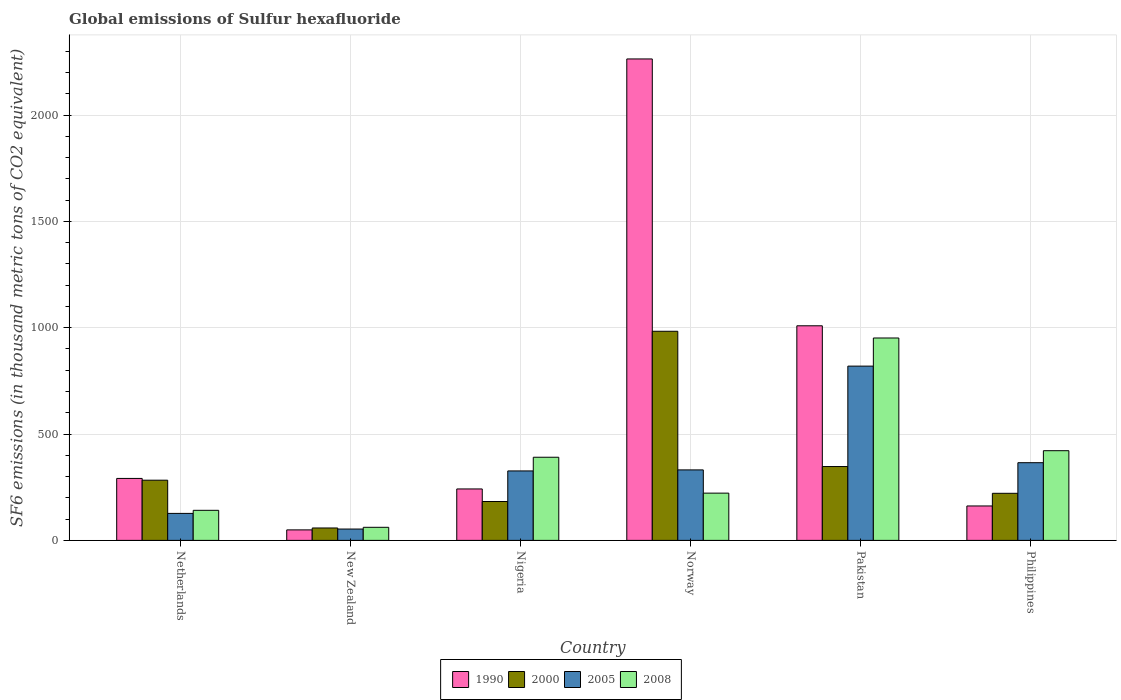How many different coloured bars are there?
Your answer should be very brief. 4. How many groups of bars are there?
Ensure brevity in your answer.  6. Are the number of bars per tick equal to the number of legend labels?
Your answer should be very brief. Yes. How many bars are there on the 3rd tick from the left?
Your response must be concise. 4. What is the label of the 6th group of bars from the left?
Give a very brief answer. Philippines. In how many cases, is the number of bars for a given country not equal to the number of legend labels?
Keep it short and to the point. 0. What is the global emissions of Sulfur hexafluoride in 1990 in New Zealand?
Keep it short and to the point. 49.4. Across all countries, what is the maximum global emissions of Sulfur hexafluoride in 2005?
Ensure brevity in your answer.  819.4. Across all countries, what is the minimum global emissions of Sulfur hexafluoride in 1990?
Your answer should be very brief. 49.4. In which country was the global emissions of Sulfur hexafluoride in 1990 maximum?
Provide a succinct answer. Norway. In which country was the global emissions of Sulfur hexafluoride in 2000 minimum?
Your response must be concise. New Zealand. What is the total global emissions of Sulfur hexafluoride in 1990 in the graph?
Offer a very short reply. 4017.1. What is the difference between the global emissions of Sulfur hexafluoride in 1990 in Netherlands and that in Nigeria?
Provide a short and direct response. 49.4. What is the difference between the global emissions of Sulfur hexafluoride in 2008 in New Zealand and the global emissions of Sulfur hexafluoride in 1990 in Netherlands?
Keep it short and to the point. -229.8. What is the average global emissions of Sulfur hexafluoride in 2000 per country?
Your answer should be very brief. 346. What is the difference between the global emissions of Sulfur hexafluoride of/in 1990 and global emissions of Sulfur hexafluoride of/in 2005 in Pakistan?
Provide a succinct answer. 189.6. What is the ratio of the global emissions of Sulfur hexafluoride in 1990 in Pakistan to that in Philippines?
Make the answer very short. 6.23. Is the global emissions of Sulfur hexafluoride in 2000 in Norway less than that in Pakistan?
Give a very brief answer. No. What is the difference between the highest and the second highest global emissions of Sulfur hexafluoride in 2005?
Provide a short and direct response. -488. What is the difference between the highest and the lowest global emissions of Sulfur hexafluoride in 2005?
Keep it short and to the point. 766. In how many countries, is the global emissions of Sulfur hexafluoride in 1990 greater than the average global emissions of Sulfur hexafluoride in 1990 taken over all countries?
Your answer should be very brief. 2. Is it the case that in every country, the sum of the global emissions of Sulfur hexafluoride in 2008 and global emissions of Sulfur hexafluoride in 2000 is greater than the sum of global emissions of Sulfur hexafluoride in 2005 and global emissions of Sulfur hexafluoride in 1990?
Ensure brevity in your answer.  No. What does the 3rd bar from the right in Pakistan represents?
Your answer should be compact. 2000. How many bars are there?
Keep it short and to the point. 24. Are all the bars in the graph horizontal?
Your answer should be compact. No. Are the values on the major ticks of Y-axis written in scientific E-notation?
Keep it short and to the point. No. Does the graph contain any zero values?
Your answer should be very brief. No. Where does the legend appear in the graph?
Offer a terse response. Bottom center. How are the legend labels stacked?
Give a very brief answer. Horizontal. What is the title of the graph?
Keep it short and to the point. Global emissions of Sulfur hexafluoride. What is the label or title of the X-axis?
Ensure brevity in your answer.  Country. What is the label or title of the Y-axis?
Provide a short and direct response. SF6 emissions (in thousand metric tons of CO2 equivalent). What is the SF6 emissions (in thousand metric tons of CO2 equivalent) in 1990 in Netherlands?
Offer a terse response. 291.3. What is the SF6 emissions (in thousand metric tons of CO2 equivalent) in 2000 in Netherlands?
Provide a short and direct response. 283. What is the SF6 emissions (in thousand metric tons of CO2 equivalent) of 2005 in Netherlands?
Your response must be concise. 126.9. What is the SF6 emissions (in thousand metric tons of CO2 equivalent) of 2008 in Netherlands?
Your response must be concise. 141.4. What is the SF6 emissions (in thousand metric tons of CO2 equivalent) in 1990 in New Zealand?
Ensure brevity in your answer.  49.4. What is the SF6 emissions (in thousand metric tons of CO2 equivalent) of 2000 in New Zealand?
Provide a short and direct response. 58.4. What is the SF6 emissions (in thousand metric tons of CO2 equivalent) in 2005 in New Zealand?
Ensure brevity in your answer.  53.4. What is the SF6 emissions (in thousand metric tons of CO2 equivalent) in 2008 in New Zealand?
Your response must be concise. 61.5. What is the SF6 emissions (in thousand metric tons of CO2 equivalent) in 1990 in Nigeria?
Give a very brief answer. 241.9. What is the SF6 emissions (in thousand metric tons of CO2 equivalent) of 2000 in Nigeria?
Your response must be concise. 182.8. What is the SF6 emissions (in thousand metric tons of CO2 equivalent) in 2005 in Nigeria?
Your answer should be compact. 326.6. What is the SF6 emissions (in thousand metric tons of CO2 equivalent) in 2008 in Nigeria?
Make the answer very short. 390.9. What is the SF6 emissions (in thousand metric tons of CO2 equivalent) in 1990 in Norway?
Make the answer very short. 2263.6. What is the SF6 emissions (in thousand metric tons of CO2 equivalent) in 2000 in Norway?
Your response must be concise. 983.2. What is the SF6 emissions (in thousand metric tons of CO2 equivalent) of 2005 in Norway?
Make the answer very short. 331.4. What is the SF6 emissions (in thousand metric tons of CO2 equivalent) in 2008 in Norway?
Give a very brief answer. 222.2. What is the SF6 emissions (in thousand metric tons of CO2 equivalent) in 1990 in Pakistan?
Make the answer very short. 1009. What is the SF6 emissions (in thousand metric tons of CO2 equivalent) in 2000 in Pakistan?
Offer a very short reply. 347.2. What is the SF6 emissions (in thousand metric tons of CO2 equivalent) of 2005 in Pakistan?
Ensure brevity in your answer.  819.4. What is the SF6 emissions (in thousand metric tons of CO2 equivalent) of 2008 in Pakistan?
Your answer should be very brief. 951.6. What is the SF6 emissions (in thousand metric tons of CO2 equivalent) of 1990 in Philippines?
Provide a short and direct response. 161.9. What is the SF6 emissions (in thousand metric tons of CO2 equivalent) in 2000 in Philippines?
Your answer should be very brief. 221.4. What is the SF6 emissions (in thousand metric tons of CO2 equivalent) of 2005 in Philippines?
Your response must be concise. 365.3. What is the SF6 emissions (in thousand metric tons of CO2 equivalent) of 2008 in Philippines?
Offer a very short reply. 421.7. Across all countries, what is the maximum SF6 emissions (in thousand metric tons of CO2 equivalent) in 1990?
Your answer should be compact. 2263.6. Across all countries, what is the maximum SF6 emissions (in thousand metric tons of CO2 equivalent) of 2000?
Make the answer very short. 983.2. Across all countries, what is the maximum SF6 emissions (in thousand metric tons of CO2 equivalent) in 2005?
Give a very brief answer. 819.4. Across all countries, what is the maximum SF6 emissions (in thousand metric tons of CO2 equivalent) in 2008?
Make the answer very short. 951.6. Across all countries, what is the minimum SF6 emissions (in thousand metric tons of CO2 equivalent) in 1990?
Your answer should be very brief. 49.4. Across all countries, what is the minimum SF6 emissions (in thousand metric tons of CO2 equivalent) of 2000?
Provide a succinct answer. 58.4. Across all countries, what is the minimum SF6 emissions (in thousand metric tons of CO2 equivalent) in 2005?
Ensure brevity in your answer.  53.4. Across all countries, what is the minimum SF6 emissions (in thousand metric tons of CO2 equivalent) of 2008?
Offer a terse response. 61.5. What is the total SF6 emissions (in thousand metric tons of CO2 equivalent) of 1990 in the graph?
Ensure brevity in your answer.  4017.1. What is the total SF6 emissions (in thousand metric tons of CO2 equivalent) in 2000 in the graph?
Give a very brief answer. 2076. What is the total SF6 emissions (in thousand metric tons of CO2 equivalent) of 2005 in the graph?
Keep it short and to the point. 2023. What is the total SF6 emissions (in thousand metric tons of CO2 equivalent) in 2008 in the graph?
Provide a short and direct response. 2189.3. What is the difference between the SF6 emissions (in thousand metric tons of CO2 equivalent) of 1990 in Netherlands and that in New Zealand?
Your answer should be very brief. 241.9. What is the difference between the SF6 emissions (in thousand metric tons of CO2 equivalent) in 2000 in Netherlands and that in New Zealand?
Ensure brevity in your answer.  224.6. What is the difference between the SF6 emissions (in thousand metric tons of CO2 equivalent) of 2005 in Netherlands and that in New Zealand?
Your answer should be very brief. 73.5. What is the difference between the SF6 emissions (in thousand metric tons of CO2 equivalent) of 2008 in Netherlands and that in New Zealand?
Make the answer very short. 79.9. What is the difference between the SF6 emissions (in thousand metric tons of CO2 equivalent) of 1990 in Netherlands and that in Nigeria?
Your response must be concise. 49.4. What is the difference between the SF6 emissions (in thousand metric tons of CO2 equivalent) in 2000 in Netherlands and that in Nigeria?
Ensure brevity in your answer.  100.2. What is the difference between the SF6 emissions (in thousand metric tons of CO2 equivalent) of 2005 in Netherlands and that in Nigeria?
Your answer should be very brief. -199.7. What is the difference between the SF6 emissions (in thousand metric tons of CO2 equivalent) in 2008 in Netherlands and that in Nigeria?
Offer a terse response. -249.5. What is the difference between the SF6 emissions (in thousand metric tons of CO2 equivalent) of 1990 in Netherlands and that in Norway?
Keep it short and to the point. -1972.3. What is the difference between the SF6 emissions (in thousand metric tons of CO2 equivalent) in 2000 in Netherlands and that in Norway?
Offer a terse response. -700.2. What is the difference between the SF6 emissions (in thousand metric tons of CO2 equivalent) in 2005 in Netherlands and that in Norway?
Give a very brief answer. -204.5. What is the difference between the SF6 emissions (in thousand metric tons of CO2 equivalent) in 2008 in Netherlands and that in Norway?
Your answer should be very brief. -80.8. What is the difference between the SF6 emissions (in thousand metric tons of CO2 equivalent) in 1990 in Netherlands and that in Pakistan?
Offer a very short reply. -717.7. What is the difference between the SF6 emissions (in thousand metric tons of CO2 equivalent) in 2000 in Netherlands and that in Pakistan?
Offer a very short reply. -64.2. What is the difference between the SF6 emissions (in thousand metric tons of CO2 equivalent) in 2005 in Netherlands and that in Pakistan?
Ensure brevity in your answer.  -692.5. What is the difference between the SF6 emissions (in thousand metric tons of CO2 equivalent) in 2008 in Netherlands and that in Pakistan?
Your answer should be very brief. -810.2. What is the difference between the SF6 emissions (in thousand metric tons of CO2 equivalent) of 1990 in Netherlands and that in Philippines?
Offer a very short reply. 129.4. What is the difference between the SF6 emissions (in thousand metric tons of CO2 equivalent) in 2000 in Netherlands and that in Philippines?
Keep it short and to the point. 61.6. What is the difference between the SF6 emissions (in thousand metric tons of CO2 equivalent) of 2005 in Netherlands and that in Philippines?
Make the answer very short. -238.4. What is the difference between the SF6 emissions (in thousand metric tons of CO2 equivalent) in 2008 in Netherlands and that in Philippines?
Your response must be concise. -280.3. What is the difference between the SF6 emissions (in thousand metric tons of CO2 equivalent) in 1990 in New Zealand and that in Nigeria?
Offer a terse response. -192.5. What is the difference between the SF6 emissions (in thousand metric tons of CO2 equivalent) of 2000 in New Zealand and that in Nigeria?
Your answer should be very brief. -124.4. What is the difference between the SF6 emissions (in thousand metric tons of CO2 equivalent) of 2005 in New Zealand and that in Nigeria?
Your answer should be very brief. -273.2. What is the difference between the SF6 emissions (in thousand metric tons of CO2 equivalent) of 2008 in New Zealand and that in Nigeria?
Your answer should be very brief. -329.4. What is the difference between the SF6 emissions (in thousand metric tons of CO2 equivalent) of 1990 in New Zealand and that in Norway?
Your answer should be compact. -2214.2. What is the difference between the SF6 emissions (in thousand metric tons of CO2 equivalent) in 2000 in New Zealand and that in Norway?
Your answer should be compact. -924.8. What is the difference between the SF6 emissions (in thousand metric tons of CO2 equivalent) of 2005 in New Zealand and that in Norway?
Your answer should be very brief. -278. What is the difference between the SF6 emissions (in thousand metric tons of CO2 equivalent) of 2008 in New Zealand and that in Norway?
Provide a short and direct response. -160.7. What is the difference between the SF6 emissions (in thousand metric tons of CO2 equivalent) of 1990 in New Zealand and that in Pakistan?
Keep it short and to the point. -959.6. What is the difference between the SF6 emissions (in thousand metric tons of CO2 equivalent) in 2000 in New Zealand and that in Pakistan?
Provide a succinct answer. -288.8. What is the difference between the SF6 emissions (in thousand metric tons of CO2 equivalent) in 2005 in New Zealand and that in Pakistan?
Your answer should be compact. -766. What is the difference between the SF6 emissions (in thousand metric tons of CO2 equivalent) in 2008 in New Zealand and that in Pakistan?
Provide a short and direct response. -890.1. What is the difference between the SF6 emissions (in thousand metric tons of CO2 equivalent) in 1990 in New Zealand and that in Philippines?
Your response must be concise. -112.5. What is the difference between the SF6 emissions (in thousand metric tons of CO2 equivalent) in 2000 in New Zealand and that in Philippines?
Your answer should be compact. -163. What is the difference between the SF6 emissions (in thousand metric tons of CO2 equivalent) of 2005 in New Zealand and that in Philippines?
Give a very brief answer. -311.9. What is the difference between the SF6 emissions (in thousand metric tons of CO2 equivalent) in 2008 in New Zealand and that in Philippines?
Offer a terse response. -360.2. What is the difference between the SF6 emissions (in thousand metric tons of CO2 equivalent) in 1990 in Nigeria and that in Norway?
Give a very brief answer. -2021.7. What is the difference between the SF6 emissions (in thousand metric tons of CO2 equivalent) in 2000 in Nigeria and that in Norway?
Offer a terse response. -800.4. What is the difference between the SF6 emissions (in thousand metric tons of CO2 equivalent) in 2005 in Nigeria and that in Norway?
Your answer should be very brief. -4.8. What is the difference between the SF6 emissions (in thousand metric tons of CO2 equivalent) in 2008 in Nigeria and that in Norway?
Offer a terse response. 168.7. What is the difference between the SF6 emissions (in thousand metric tons of CO2 equivalent) of 1990 in Nigeria and that in Pakistan?
Keep it short and to the point. -767.1. What is the difference between the SF6 emissions (in thousand metric tons of CO2 equivalent) in 2000 in Nigeria and that in Pakistan?
Offer a very short reply. -164.4. What is the difference between the SF6 emissions (in thousand metric tons of CO2 equivalent) in 2005 in Nigeria and that in Pakistan?
Offer a terse response. -492.8. What is the difference between the SF6 emissions (in thousand metric tons of CO2 equivalent) of 2008 in Nigeria and that in Pakistan?
Provide a succinct answer. -560.7. What is the difference between the SF6 emissions (in thousand metric tons of CO2 equivalent) of 1990 in Nigeria and that in Philippines?
Your answer should be very brief. 80. What is the difference between the SF6 emissions (in thousand metric tons of CO2 equivalent) of 2000 in Nigeria and that in Philippines?
Offer a terse response. -38.6. What is the difference between the SF6 emissions (in thousand metric tons of CO2 equivalent) of 2005 in Nigeria and that in Philippines?
Provide a short and direct response. -38.7. What is the difference between the SF6 emissions (in thousand metric tons of CO2 equivalent) in 2008 in Nigeria and that in Philippines?
Offer a very short reply. -30.8. What is the difference between the SF6 emissions (in thousand metric tons of CO2 equivalent) in 1990 in Norway and that in Pakistan?
Your response must be concise. 1254.6. What is the difference between the SF6 emissions (in thousand metric tons of CO2 equivalent) in 2000 in Norway and that in Pakistan?
Your answer should be very brief. 636. What is the difference between the SF6 emissions (in thousand metric tons of CO2 equivalent) in 2005 in Norway and that in Pakistan?
Keep it short and to the point. -488. What is the difference between the SF6 emissions (in thousand metric tons of CO2 equivalent) in 2008 in Norway and that in Pakistan?
Offer a terse response. -729.4. What is the difference between the SF6 emissions (in thousand metric tons of CO2 equivalent) of 1990 in Norway and that in Philippines?
Provide a short and direct response. 2101.7. What is the difference between the SF6 emissions (in thousand metric tons of CO2 equivalent) in 2000 in Norway and that in Philippines?
Offer a terse response. 761.8. What is the difference between the SF6 emissions (in thousand metric tons of CO2 equivalent) of 2005 in Norway and that in Philippines?
Your answer should be very brief. -33.9. What is the difference between the SF6 emissions (in thousand metric tons of CO2 equivalent) in 2008 in Norway and that in Philippines?
Your answer should be compact. -199.5. What is the difference between the SF6 emissions (in thousand metric tons of CO2 equivalent) of 1990 in Pakistan and that in Philippines?
Keep it short and to the point. 847.1. What is the difference between the SF6 emissions (in thousand metric tons of CO2 equivalent) in 2000 in Pakistan and that in Philippines?
Give a very brief answer. 125.8. What is the difference between the SF6 emissions (in thousand metric tons of CO2 equivalent) of 2005 in Pakistan and that in Philippines?
Your response must be concise. 454.1. What is the difference between the SF6 emissions (in thousand metric tons of CO2 equivalent) in 2008 in Pakistan and that in Philippines?
Make the answer very short. 529.9. What is the difference between the SF6 emissions (in thousand metric tons of CO2 equivalent) of 1990 in Netherlands and the SF6 emissions (in thousand metric tons of CO2 equivalent) of 2000 in New Zealand?
Offer a terse response. 232.9. What is the difference between the SF6 emissions (in thousand metric tons of CO2 equivalent) of 1990 in Netherlands and the SF6 emissions (in thousand metric tons of CO2 equivalent) of 2005 in New Zealand?
Offer a terse response. 237.9. What is the difference between the SF6 emissions (in thousand metric tons of CO2 equivalent) in 1990 in Netherlands and the SF6 emissions (in thousand metric tons of CO2 equivalent) in 2008 in New Zealand?
Offer a very short reply. 229.8. What is the difference between the SF6 emissions (in thousand metric tons of CO2 equivalent) in 2000 in Netherlands and the SF6 emissions (in thousand metric tons of CO2 equivalent) in 2005 in New Zealand?
Your response must be concise. 229.6. What is the difference between the SF6 emissions (in thousand metric tons of CO2 equivalent) in 2000 in Netherlands and the SF6 emissions (in thousand metric tons of CO2 equivalent) in 2008 in New Zealand?
Give a very brief answer. 221.5. What is the difference between the SF6 emissions (in thousand metric tons of CO2 equivalent) of 2005 in Netherlands and the SF6 emissions (in thousand metric tons of CO2 equivalent) of 2008 in New Zealand?
Provide a short and direct response. 65.4. What is the difference between the SF6 emissions (in thousand metric tons of CO2 equivalent) in 1990 in Netherlands and the SF6 emissions (in thousand metric tons of CO2 equivalent) in 2000 in Nigeria?
Provide a short and direct response. 108.5. What is the difference between the SF6 emissions (in thousand metric tons of CO2 equivalent) in 1990 in Netherlands and the SF6 emissions (in thousand metric tons of CO2 equivalent) in 2005 in Nigeria?
Provide a succinct answer. -35.3. What is the difference between the SF6 emissions (in thousand metric tons of CO2 equivalent) in 1990 in Netherlands and the SF6 emissions (in thousand metric tons of CO2 equivalent) in 2008 in Nigeria?
Ensure brevity in your answer.  -99.6. What is the difference between the SF6 emissions (in thousand metric tons of CO2 equivalent) of 2000 in Netherlands and the SF6 emissions (in thousand metric tons of CO2 equivalent) of 2005 in Nigeria?
Your answer should be very brief. -43.6. What is the difference between the SF6 emissions (in thousand metric tons of CO2 equivalent) in 2000 in Netherlands and the SF6 emissions (in thousand metric tons of CO2 equivalent) in 2008 in Nigeria?
Your answer should be very brief. -107.9. What is the difference between the SF6 emissions (in thousand metric tons of CO2 equivalent) of 2005 in Netherlands and the SF6 emissions (in thousand metric tons of CO2 equivalent) of 2008 in Nigeria?
Your answer should be compact. -264. What is the difference between the SF6 emissions (in thousand metric tons of CO2 equivalent) of 1990 in Netherlands and the SF6 emissions (in thousand metric tons of CO2 equivalent) of 2000 in Norway?
Give a very brief answer. -691.9. What is the difference between the SF6 emissions (in thousand metric tons of CO2 equivalent) in 1990 in Netherlands and the SF6 emissions (in thousand metric tons of CO2 equivalent) in 2005 in Norway?
Keep it short and to the point. -40.1. What is the difference between the SF6 emissions (in thousand metric tons of CO2 equivalent) in 1990 in Netherlands and the SF6 emissions (in thousand metric tons of CO2 equivalent) in 2008 in Norway?
Ensure brevity in your answer.  69.1. What is the difference between the SF6 emissions (in thousand metric tons of CO2 equivalent) of 2000 in Netherlands and the SF6 emissions (in thousand metric tons of CO2 equivalent) of 2005 in Norway?
Keep it short and to the point. -48.4. What is the difference between the SF6 emissions (in thousand metric tons of CO2 equivalent) in 2000 in Netherlands and the SF6 emissions (in thousand metric tons of CO2 equivalent) in 2008 in Norway?
Provide a short and direct response. 60.8. What is the difference between the SF6 emissions (in thousand metric tons of CO2 equivalent) of 2005 in Netherlands and the SF6 emissions (in thousand metric tons of CO2 equivalent) of 2008 in Norway?
Make the answer very short. -95.3. What is the difference between the SF6 emissions (in thousand metric tons of CO2 equivalent) of 1990 in Netherlands and the SF6 emissions (in thousand metric tons of CO2 equivalent) of 2000 in Pakistan?
Your answer should be very brief. -55.9. What is the difference between the SF6 emissions (in thousand metric tons of CO2 equivalent) in 1990 in Netherlands and the SF6 emissions (in thousand metric tons of CO2 equivalent) in 2005 in Pakistan?
Provide a succinct answer. -528.1. What is the difference between the SF6 emissions (in thousand metric tons of CO2 equivalent) of 1990 in Netherlands and the SF6 emissions (in thousand metric tons of CO2 equivalent) of 2008 in Pakistan?
Give a very brief answer. -660.3. What is the difference between the SF6 emissions (in thousand metric tons of CO2 equivalent) of 2000 in Netherlands and the SF6 emissions (in thousand metric tons of CO2 equivalent) of 2005 in Pakistan?
Make the answer very short. -536.4. What is the difference between the SF6 emissions (in thousand metric tons of CO2 equivalent) in 2000 in Netherlands and the SF6 emissions (in thousand metric tons of CO2 equivalent) in 2008 in Pakistan?
Your answer should be compact. -668.6. What is the difference between the SF6 emissions (in thousand metric tons of CO2 equivalent) in 2005 in Netherlands and the SF6 emissions (in thousand metric tons of CO2 equivalent) in 2008 in Pakistan?
Offer a very short reply. -824.7. What is the difference between the SF6 emissions (in thousand metric tons of CO2 equivalent) of 1990 in Netherlands and the SF6 emissions (in thousand metric tons of CO2 equivalent) of 2000 in Philippines?
Offer a terse response. 69.9. What is the difference between the SF6 emissions (in thousand metric tons of CO2 equivalent) in 1990 in Netherlands and the SF6 emissions (in thousand metric tons of CO2 equivalent) in 2005 in Philippines?
Your response must be concise. -74. What is the difference between the SF6 emissions (in thousand metric tons of CO2 equivalent) of 1990 in Netherlands and the SF6 emissions (in thousand metric tons of CO2 equivalent) of 2008 in Philippines?
Your answer should be very brief. -130.4. What is the difference between the SF6 emissions (in thousand metric tons of CO2 equivalent) of 2000 in Netherlands and the SF6 emissions (in thousand metric tons of CO2 equivalent) of 2005 in Philippines?
Ensure brevity in your answer.  -82.3. What is the difference between the SF6 emissions (in thousand metric tons of CO2 equivalent) of 2000 in Netherlands and the SF6 emissions (in thousand metric tons of CO2 equivalent) of 2008 in Philippines?
Offer a terse response. -138.7. What is the difference between the SF6 emissions (in thousand metric tons of CO2 equivalent) in 2005 in Netherlands and the SF6 emissions (in thousand metric tons of CO2 equivalent) in 2008 in Philippines?
Your answer should be very brief. -294.8. What is the difference between the SF6 emissions (in thousand metric tons of CO2 equivalent) of 1990 in New Zealand and the SF6 emissions (in thousand metric tons of CO2 equivalent) of 2000 in Nigeria?
Your response must be concise. -133.4. What is the difference between the SF6 emissions (in thousand metric tons of CO2 equivalent) of 1990 in New Zealand and the SF6 emissions (in thousand metric tons of CO2 equivalent) of 2005 in Nigeria?
Ensure brevity in your answer.  -277.2. What is the difference between the SF6 emissions (in thousand metric tons of CO2 equivalent) in 1990 in New Zealand and the SF6 emissions (in thousand metric tons of CO2 equivalent) in 2008 in Nigeria?
Give a very brief answer. -341.5. What is the difference between the SF6 emissions (in thousand metric tons of CO2 equivalent) in 2000 in New Zealand and the SF6 emissions (in thousand metric tons of CO2 equivalent) in 2005 in Nigeria?
Offer a very short reply. -268.2. What is the difference between the SF6 emissions (in thousand metric tons of CO2 equivalent) in 2000 in New Zealand and the SF6 emissions (in thousand metric tons of CO2 equivalent) in 2008 in Nigeria?
Ensure brevity in your answer.  -332.5. What is the difference between the SF6 emissions (in thousand metric tons of CO2 equivalent) in 2005 in New Zealand and the SF6 emissions (in thousand metric tons of CO2 equivalent) in 2008 in Nigeria?
Make the answer very short. -337.5. What is the difference between the SF6 emissions (in thousand metric tons of CO2 equivalent) of 1990 in New Zealand and the SF6 emissions (in thousand metric tons of CO2 equivalent) of 2000 in Norway?
Ensure brevity in your answer.  -933.8. What is the difference between the SF6 emissions (in thousand metric tons of CO2 equivalent) in 1990 in New Zealand and the SF6 emissions (in thousand metric tons of CO2 equivalent) in 2005 in Norway?
Give a very brief answer. -282. What is the difference between the SF6 emissions (in thousand metric tons of CO2 equivalent) of 1990 in New Zealand and the SF6 emissions (in thousand metric tons of CO2 equivalent) of 2008 in Norway?
Give a very brief answer. -172.8. What is the difference between the SF6 emissions (in thousand metric tons of CO2 equivalent) in 2000 in New Zealand and the SF6 emissions (in thousand metric tons of CO2 equivalent) in 2005 in Norway?
Provide a succinct answer. -273. What is the difference between the SF6 emissions (in thousand metric tons of CO2 equivalent) in 2000 in New Zealand and the SF6 emissions (in thousand metric tons of CO2 equivalent) in 2008 in Norway?
Your response must be concise. -163.8. What is the difference between the SF6 emissions (in thousand metric tons of CO2 equivalent) of 2005 in New Zealand and the SF6 emissions (in thousand metric tons of CO2 equivalent) of 2008 in Norway?
Offer a terse response. -168.8. What is the difference between the SF6 emissions (in thousand metric tons of CO2 equivalent) of 1990 in New Zealand and the SF6 emissions (in thousand metric tons of CO2 equivalent) of 2000 in Pakistan?
Give a very brief answer. -297.8. What is the difference between the SF6 emissions (in thousand metric tons of CO2 equivalent) in 1990 in New Zealand and the SF6 emissions (in thousand metric tons of CO2 equivalent) in 2005 in Pakistan?
Make the answer very short. -770. What is the difference between the SF6 emissions (in thousand metric tons of CO2 equivalent) in 1990 in New Zealand and the SF6 emissions (in thousand metric tons of CO2 equivalent) in 2008 in Pakistan?
Give a very brief answer. -902.2. What is the difference between the SF6 emissions (in thousand metric tons of CO2 equivalent) of 2000 in New Zealand and the SF6 emissions (in thousand metric tons of CO2 equivalent) of 2005 in Pakistan?
Your answer should be compact. -761. What is the difference between the SF6 emissions (in thousand metric tons of CO2 equivalent) in 2000 in New Zealand and the SF6 emissions (in thousand metric tons of CO2 equivalent) in 2008 in Pakistan?
Keep it short and to the point. -893.2. What is the difference between the SF6 emissions (in thousand metric tons of CO2 equivalent) in 2005 in New Zealand and the SF6 emissions (in thousand metric tons of CO2 equivalent) in 2008 in Pakistan?
Your answer should be very brief. -898.2. What is the difference between the SF6 emissions (in thousand metric tons of CO2 equivalent) in 1990 in New Zealand and the SF6 emissions (in thousand metric tons of CO2 equivalent) in 2000 in Philippines?
Your answer should be compact. -172. What is the difference between the SF6 emissions (in thousand metric tons of CO2 equivalent) of 1990 in New Zealand and the SF6 emissions (in thousand metric tons of CO2 equivalent) of 2005 in Philippines?
Give a very brief answer. -315.9. What is the difference between the SF6 emissions (in thousand metric tons of CO2 equivalent) in 1990 in New Zealand and the SF6 emissions (in thousand metric tons of CO2 equivalent) in 2008 in Philippines?
Make the answer very short. -372.3. What is the difference between the SF6 emissions (in thousand metric tons of CO2 equivalent) of 2000 in New Zealand and the SF6 emissions (in thousand metric tons of CO2 equivalent) of 2005 in Philippines?
Offer a very short reply. -306.9. What is the difference between the SF6 emissions (in thousand metric tons of CO2 equivalent) in 2000 in New Zealand and the SF6 emissions (in thousand metric tons of CO2 equivalent) in 2008 in Philippines?
Your answer should be very brief. -363.3. What is the difference between the SF6 emissions (in thousand metric tons of CO2 equivalent) in 2005 in New Zealand and the SF6 emissions (in thousand metric tons of CO2 equivalent) in 2008 in Philippines?
Keep it short and to the point. -368.3. What is the difference between the SF6 emissions (in thousand metric tons of CO2 equivalent) of 1990 in Nigeria and the SF6 emissions (in thousand metric tons of CO2 equivalent) of 2000 in Norway?
Give a very brief answer. -741.3. What is the difference between the SF6 emissions (in thousand metric tons of CO2 equivalent) of 1990 in Nigeria and the SF6 emissions (in thousand metric tons of CO2 equivalent) of 2005 in Norway?
Keep it short and to the point. -89.5. What is the difference between the SF6 emissions (in thousand metric tons of CO2 equivalent) of 1990 in Nigeria and the SF6 emissions (in thousand metric tons of CO2 equivalent) of 2008 in Norway?
Your response must be concise. 19.7. What is the difference between the SF6 emissions (in thousand metric tons of CO2 equivalent) of 2000 in Nigeria and the SF6 emissions (in thousand metric tons of CO2 equivalent) of 2005 in Norway?
Give a very brief answer. -148.6. What is the difference between the SF6 emissions (in thousand metric tons of CO2 equivalent) of 2000 in Nigeria and the SF6 emissions (in thousand metric tons of CO2 equivalent) of 2008 in Norway?
Make the answer very short. -39.4. What is the difference between the SF6 emissions (in thousand metric tons of CO2 equivalent) in 2005 in Nigeria and the SF6 emissions (in thousand metric tons of CO2 equivalent) in 2008 in Norway?
Make the answer very short. 104.4. What is the difference between the SF6 emissions (in thousand metric tons of CO2 equivalent) of 1990 in Nigeria and the SF6 emissions (in thousand metric tons of CO2 equivalent) of 2000 in Pakistan?
Offer a very short reply. -105.3. What is the difference between the SF6 emissions (in thousand metric tons of CO2 equivalent) of 1990 in Nigeria and the SF6 emissions (in thousand metric tons of CO2 equivalent) of 2005 in Pakistan?
Your response must be concise. -577.5. What is the difference between the SF6 emissions (in thousand metric tons of CO2 equivalent) in 1990 in Nigeria and the SF6 emissions (in thousand metric tons of CO2 equivalent) in 2008 in Pakistan?
Provide a short and direct response. -709.7. What is the difference between the SF6 emissions (in thousand metric tons of CO2 equivalent) of 2000 in Nigeria and the SF6 emissions (in thousand metric tons of CO2 equivalent) of 2005 in Pakistan?
Provide a short and direct response. -636.6. What is the difference between the SF6 emissions (in thousand metric tons of CO2 equivalent) of 2000 in Nigeria and the SF6 emissions (in thousand metric tons of CO2 equivalent) of 2008 in Pakistan?
Make the answer very short. -768.8. What is the difference between the SF6 emissions (in thousand metric tons of CO2 equivalent) in 2005 in Nigeria and the SF6 emissions (in thousand metric tons of CO2 equivalent) in 2008 in Pakistan?
Provide a short and direct response. -625. What is the difference between the SF6 emissions (in thousand metric tons of CO2 equivalent) in 1990 in Nigeria and the SF6 emissions (in thousand metric tons of CO2 equivalent) in 2000 in Philippines?
Ensure brevity in your answer.  20.5. What is the difference between the SF6 emissions (in thousand metric tons of CO2 equivalent) in 1990 in Nigeria and the SF6 emissions (in thousand metric tons of CO2 equivalent) in 2005 in Philippines?
Ensure brevity in your answer.  -123.4. What is the difference between the SF6 emissions (in thousand metric tons of CO2 equivalent) of 1990 in Nigeria and the SF6 emissions (in thousand metric tons of CO2 equivalent) of 2008 in Philippines?
Provide a succinct answer. -179.8. What is the difference between the SF6 emissions (in thousand metric tons of CO2 equivalent) of 2000 in Nigeria and the SF6 emissions (in thousand metric tons of CO2 equivalent) of 2005 in Philippines?
Make the answer very short. -182.5. What is the difference between the SF6 emissions (in thousand metric tons of CO2 equivalent) of 2000 in Nigeria and the SF6 emissions (in thousand metric tons of CO2 equivalent) of 2008 in Philippines?
Your response must be concise. -238.9. What is the difference between the SF6 emissions (in thousand metric tons of CO2 equivalent) of 2005 in Nigeria and the SF6 emissions (in thousand metric tons of CO2 equivalent) of 2008 in Philippines?
Provide a succinct answer. -95.1. What is the difference between the SF6 emissions (in thousand metric tons of CO2 equivalent) in 1990 in Norway and the SF6 emissions (in thousand metric tons of CO2 equivalent) in 2000 in Pakistan?
Your answer should be very brief. 1916.4. What is the difference between the SF6 emissions (in thousand metric tons of CO2 equivalent) of 1990 in Norway and the SF6 emissions (in thousand metric tons of CO2 equivalent) of 2005 in Pakistan?
Give a very brief answer. 1444.2. What is the difference between the SF6 emissions (in thousand metric tons of CO2 equivalent) of 1990 in Norway and the SF6 emissions (in thousand metric tons of CO2 equivalent) of 2008 in Pakistan?
Your response must be concise. 1312. What is the difference between the SF6 emissions (in thousand metric tons of CO2 equivalent) in 2000 in Norway and the SF6 emissions (in thousand metric tons of CO2 equivalent) in 2005 in Pakistan?
Your answer should be very brief. 163.8. What is the difference between the SF6 emissions (in thousand metric tons of CO2 equivalent) in 2000 in Norway and the SF6 emissions (in thousand metric tons of CO2 equivalent) in 2008 in Pakistan?
Give a very brief answer. 31.6. What is the difference between the SF6 emissions (in thousand metric tons of CO2 equivalent) in 2005 in Norway and the SF6 emissions (in thousand metric tons of CO2 equivalent) in 2008 in Pakistan?
Keep it short and to the point. -620.2. What is the difference between the SF6 emissions (in thousand metric tons of CO2 equivalent) of 1990 in Norway and the SF6 emissions (in thousand metric tons of CO2 equivalent) of 2000 in Philippines?
Make the answer very short. 2042.2. What is the difference between the SF6 emissions (in thousand metric tons of CO2 equivalent) in 1990 in Norway and the SF6 emissions (in thousand metric tons of CO2 equivalent) in 2005 in Philippines?
Provide a short and direct response. 1898.3. What is the difference between the SF6 emissions (in thousand metric tons of CO2 equivalent) of 1990 in Norway and the SF6 emissions (in thousand metric tons of CO2 equivalent) of 2008 in Philippines?
Ensure brevity in your answer.  1841.9. What is the difference between the SF6 emissions (in thousand metric tons of CO2 equivalent) of 2000 in Norway and the SF6 emissions (in thousand metric tons of CO2 equivalent) of 2005 in Philippines?
Keep it short and to the point. 617.9. What is the difference between the SF6 emissions (in thousand metric tons of CO2 equivalent) in 2000 in Norway and the SF6 emissions (in thousand metric tons of CO2 equivalent) in 2008 in Philippines?
Provide a short and direct response. 561.5. What is the difference between the SF6 emissions (in thousand metric tons of CO2 equivalent) of 2005 in Norway and the SF6 emissions (in thousand metric tons of CO2 equivalent) of 2008 in Philippines?
Provide a succinct answer. -90.3. What is the difference between the SF6 emissions (in thousand metric tons of CO2 equivalent) of 1990 in Pakistan and the SF6 emissions (in thousand metric tons of CO2 equivalent) of 2000 in Philippines?
Keep it short and to the point. 787.6. What is the difference between the SF6 emissions (in thousand metric tons of CO2 equivalent) in 1990 in Pakistan and the SF6 emissions (in thousand metric tons of CO2 equivalent) in 2005 in Philippines?
Make the answer very short. 643.7. What is the difference between the SF6 emissions (in thousand metric tons of CO2 equivalent) in 1990 in Pakistan and the SF6 emissions (in thousand metric tons of CO2 equivalent) in 2008 in Philippines?
Your answer should be very brief. 587.3. What is the difference between the SF6 emissions (in thousand metric tons of CO2 equivalent) of 2000 in Pakistan and the SF6 emissions (in thousand metric tons of CO2 equivalent) of 2005 in Philippines?
Keep it short and to the point. -18.1. What is the difference between the SF6 emissions (in thousand metric tons of CO2 equivalent) of 2000 in Pakistan and the SF6 emissions (in thousand metric tons of CO2 equivalent) of 2008 in Philippines?
Your answer should be very brief. -74.5. What is the difference between the SF6 emissions (in thousand metric tons of CO2 equivalent) in 2005 in Pakistan and the SF6 emissions (in thousand metric tons of CO2 equivalent) in 2008 in Philippines?
Give a very brief answer. 397.7. What is the average SF6 emissions (in thousand metric tons of CO2 equivalent) in 1990 per country?
Offer a terse response. 669.52. What is the average SF6 emissions (in thousand metric tons of CO2 equivalent) in 2000 per country?
Ensure brevity in your answer.  346. What is the average SF6 emissions (in thousand metric tons of CO2 equivalent) of 2005 per country?
Your answer should be compact. 337.17. What is the average SF6 emissions (in thousand metric tons of CO2 equivalent) of 2008 per country?
Keep it short and to the point. 364.88. What is the difference between the SF6 emissions (in thousand metric tons of CO2 equivalent) of 1990 and SF6 emissions (in thousand metric tons of CO2 equivalent) of 2005 in Netherlands?
Make the answer very short. 164.4. What is the difference between the SF6 emissions (in thousand metric tons of CO2 equivalent) in 1990 and SF6 emissions (in thousand metric tons of CO2 equivalent) in 2008 in Netherlands?
Offer a very short reply. 149.9. What is the difference between the SF6 emissions (in thousand metric tons of CO2 equivalent) in 2000 and SF6 emissions (in thousand metric tons of CO2 equivalent) in 2005 in Netherlands?
Offer a terse response. 156.1. What is the difference between the SF6 emissions (in thousand metric tons of CO2 equivalent) of 2000 and SF6 emissions (in thousand metric tons of CO2 equivalent) of 2008 in Netherlands?
Your response must be concise. 141.6. What is the difference between the SF6 emissions (in thousand metric tons of CO2 equivalent) in 1990 and SF6 emissions (in thousand metric tons of CO2 equivalent) in 2000 in New Zealand?
Provide a succinct answer. -9. What is the difference between the SF6 emissions (in thousand metric tons of CO2 equivalent) of 2000 and SF6 emissions (in thousand metric tons of CO2 equivalent) of 2005 in New Zealand?
Give a very brief answer. 5. What is the difference between the SF6 emissions (in thousand metric tons of CO2 equivalent) of 2000 and SF6 emissions (in thousand metric tons of CO2 equivalent) of 2008 in New Zealand?
Offer a very short reply. -3.1. What is the difference between the SF6 emissions (in thousand metric tons of CO2 equivalent) in 2005 and SF6 emissions (in thousand metric tons of CO2 equivalent) in 2008 in New Zealand?
Your answer should be compact. -8.1. What is the difference between the SF6 emissions (in thousand metric tons of CO2 equivalent) of 1990 and SF6 emissions (in thousand metric tons of CO2 equivalent) of 2000 in Nigeria?
Make the answer very short. 59.1. What is the difference between the SF6 emissions (in thousand metric tons of CO2 equivalent) in 1990 and SF6 emissions (in thousand metric tons of CO2 equivalent) in 2005 in Nigeria?
Ensure brevity in your answer.  -84.7. What is the difference between the SF6 emissions (in thousand metric tons of CO2 equivalent) of 1990 and SF6 emissions (in thousand metric tons of CO2 equivalent) of 2008 in Nigeria?
Provide a succinct answer. -149. What is the difference between the SF6 emissions (in thousand metric tons of CO2 equivalent) in 2000 and SF6 emissions (in thousand metric tons of CO2 equivalent) in 2005 in Nigeria?
Your response must be concise. -143.8. What is the difference between the SF6 emissions (in thousand metric tons of CO2 equivalent) in 2000 and SF6 emissions (in thousand metric tons of CO2 equivalent) in 2008 in Nigeria?
Keep it short and to the point. -208.1. What is the difference between the SF6 emissions (in thousand metric tons of CO2 equivalent) in 2005 and SF6 emissions (in thousand metric tons of CO2 equivalent) in 2008 in Nigeria?
Offer a terse response. -64.3. What is the difference between the SF6 emissions (in thousand metric tons of CO2 equivalent) in 1990 and SF6 emissions (in thousand metric tons of CO2 equivalent) in 2000 in Norway?
Your answer should be compact. 1280.4. What is the difference between the SF6 emissions (in thousand metric tons of CO2 equivalent) in 1990 and SF6 emissions (in thousand metric tons of CO2 equivalent) in 2005 in Norway?
Offer a terse response. 1932.2. What is the difference between the SF6 emissions (in thousand metric tons of CO2 equivalent) in 1990 and SF6 emissions (in thousand metric tons of CO2 equivalent) in 2008 in Norway?
Offer a very short reply. 2041.4. What is the difference between the SF6 emissions (in thousand metric tons of CO2 equivalent) in 2000 and SF6 emissions (in thousand metric tons of CO2 equivalent) in 2005 in Norway?
Make the answer very short. 651.8. What is the difference between the SF6 emissions (in thousand metric tons of CO2 equivalent) in 2000 and SF6 emissions (in thousand metric tons of CO2 equivalent) in 2008 in Norway?
Provide a succinct answer. 761. What is the difference between the SF6 emissions (in thousand metric tons of CO2 equivalent) of 2005 and SF6 emissions (in thousand metric tons of CO2 equivalent) of 2008 in Norway?
Provide a succinct answer. 109.2. What is the difference between the SF6 emissions (in thousand metric tons of CO2 equivalent) of 1990 and SF6 emissions (in thousand metric tons of CO2 equivalent) of 2000 in Pakistan?
Provide a succinct answer. 661.8. What is the difference between the SF6 emissions (in thousand metric tons of CO2 equivalent) in 1990 and SF6 emissions (in thousand metric tons of CO2 equivalent) in 2005 in Pakistan?
Your answer should be very brief. 189.6. What is the difference between the SF6 emissions (in thousand metric tons of CO2 equivalent) of 1990 and SF6 emissions (in thousand metric tons of CO2 equivalent) of 2008 in Pakistan?
Provide a short and direct response. 57.4. What is the difference between the SF6 emissions (in thousand metric tons of CO2 equivalent) of 2000 and SF6 emissions (in thousand metric tons of CO2 equivalent) of 2005 in Pakistan?
Provide a succinct answer. -472.2. What is the difference between the SF6 emissions (in thousand metric tons of CO2 equivalent) in 2000 and SF6 emissions (in thousand metric tons of CO2 equivalent) in 2008 in Pakistan?
Keep it short and to the point. -604.4. What is the difference between the SF6 emissions (in thousand metric tons of CO2 equivalent) of 2005 and SF6 emissions (in thousand metric tons of CO2 equivalent) of 2008 in Pakistan?
Ensure brevity in your answer.  -132.2. What is the difference between the SF6 emissions (in thousand metric tons of CO2 equivalent) in 1990 and SF6 emissions (in thousand metric tons of CO2 equivalent) in 2000 in Philippines?
Your answer should be compact. -59.5. What is the difference between the SF6 emissions (in thousand metric tons of CO2 equivalent) of 1990 and SF6 emissions (in thousand metric tons of CO2 equivalent) of 2005 in Philippines?
Your answer should be very brief. -203.4. What is the difference between the SF6 emissions (in thousand metric tons of CO2 equivalent) in 1990 and SF6 emissions (in thousand metric tons of CO2 equivalent) in 2008 in Philippines?
Your response must be concise. -259.8. What is the difference between the SF6 emissions (in thousand metric tons of CO2 equivalent) in 2000 and SF6 emissions (in thousand metric tons of CO2 equivalent) in 2005 in Philippines?
Make the answer very short. -143.9. What is the difference between the SF6 emissions (in thousand metric tons of CO2 equivalent) in 2000 and SF6 emissions (in thousand metric tons of CO2 equivalent) in 2008 in Philippines?
Make the answer very short. -200.3. What is the difference between the SF6 emissions (in thousand metric tons of CO2 equivalent) in 2005 and SF6 emissions (in thousand metric tons of CO2 equivalent) in 2008 in Philippines?
Provide a short and direct response. -56.4. What is the ratio of the SF6 emissions (in thousand metric tons of CO2 equivalent) of 1990 in Netherlands to that in New Zealand?
Make the answer very short. 5.9. What is the ratio of the SF6 emissions (in thousand metric tons of CO2 equivalent) of 2000 in Netherlands to that in New Zealand?
Your answer should be very brief. 4.85. What is the ratio of the SF6 emissions (in thousand metric tons of CO2 equivalent) of 2005 in Netherlands to that in New Zealand?
Provide a succinct answer. 2.38. What is the ratio of the SF6 emissions (in thousand metric tons of CO2 equivalent) in 2008 in Netherlands to that in New Zealand?
Offer a terse response. 2.3. What is the ratio of the SF6 emissions (in thousand metric tons of CO2 equivalent) in 1990 in Netherlands to that in Nigeria?
Give a very brief answer. 1.2. What is the ratio of the SF6 emissions (in thousand metric tons of CO2 equivalent) of 2000 in Netherlands to that in Nigeria?
Make the answer very short. 1.55. What is the ratio of the SF6 emissions (in thousand metric tons of CO2 equivalent) of 2005 in Netherlands to that in Nigeria?
Make the answer very short. 0.39. What is the ratio of the SF6 emissions (in thousand metric tons of CO2 equivalent) in 2008 in Netherlands to that in Nigeria?
Give a very brief answer. 0.36. What is the ratio of the SF6 emissions (in thousand metric tons of CO2 equivalent) of 1990 in Netherlands to that in Norway?
Keep it short and to the point. 0.13. What is the ratio of the SF6 emissions (in thousand metric tons of CO2 equivalent) of 2000 in Netherlands to that in Norway?
Offer a very short reply. 0.29. What is the ratio of the SF6 emissions (in thousand metric tons of CO2 equivalent) in 2005 in Netherlands to that in Norway?
Ensure brevity in your answer.  0.38. What is the ratio of the SF6 emissions (in thousand metric tons of CO2 equivalent) of 2008 in Netherlands to that in Norway?
Make the answer very short. 0.64. What is the ratio of the SF6 emissions (in thousand metric tons of CO2 equivalent) of 1990 in Netherlands to that in Pakistan?
Your answer should be very brief. 0.29. What is the ratio of the SF6 emissions (in thousand metric tons of CO2 equivalent) in 2000 in Netherlands to that in Pakistan?
Provide a succinct answer. 0.82. What is the ratio of the SF6 emissions (in thousand metric tons of CO2 equivalent) in 2005 in Netherlands to that in Pakistan?
Make the answer very short. 0.15. What is the ratio of the SF6 emissions (in thousand metric tons of CO2 equivalent) of 2008 in Netherlands to that in Pakistan?
Your response must be concise. 0.15. What is the ratio of the SF6 emissions (in thousand metric tons of CO2 equivalent) of 1990 in Netherlands to that in Philippines?
Ensure brevity in your answer.  1.8. What is the ratio of the SF6 emissions (in thousand metric tons of CO2 equivalent) of 2000 in Netherlands to that in Philippines?
Give a very brief answer. 1.28. What is the ratio of the SF6 emissions (in thousand metric tons of CO2 equivalent) in 2005 in Netherlands to that in Philippines?
Provide a succinct answer. 0.35. What is the ratio of the SF6 emissions (in thousand metric tons of CO2 equivalent) in 2008 in Netherlands to that in Philippines?
Your response must be concise. 0.34. What is the ratio of the SF6 emissions (in thousand metric tons of CO2 equivalent) in 1990 in New Zealand to that in Nigeria?
Keep it short and to the point. 0.2. What is the ratio of the SF6 emissions (in thousand metric tons of CO2 equivalent) in 2000 in New Zealand to that in Nigeria?
Your response must be concise. 0.32. What is the ratio of the SF6 emissions (in thousand metric tons of CO2 equivalent) of 2005 in New Zealand to that in Nigeria?
Your response must be concise. 0.16. What is the ratio of the SF6 emissions (in thousand metric tons of CO2 equivalent) in 2008 in New Zealand to that in Nigeria?
Provide a succinct answer. 0.16. What is the ratio of the SF6 emissions (in thousand metric tons of CO2 equivalent) in 1990 in New Zealand to that in Norway?
Offer a terse response. 0.02. What is the ratio of the SF6 emissions (in thousand metric tons of CO2 equivalent) of 2000 in New Zealand to that in Norway?
Your response must be concise. 0.06. What is the ratio of the SF6 emissions (in thousand metric tons of CO2 equivalent) in 2005 in New Zealand to that in Norway?
Offer a terse response. 0.16. What is the ratio of the SF6 emissions (in thousand metric tons of CO2 equivalent) in 2008 in New Zealand to that in Norway?
Give a very brief answer. 0.28. What is the ratio of the SF6 emissions (in thousand metric tons of CO2 equivalent) in 1990 in New Zealand to that in Pakistan?
Keep it short and to the point. 0.05. What is the ratio of the SF6 emissions (in thousand metric tons of CO2 equivalent) in 2000 in New Zealand to that in Pakistan?
Offer a terse response. 0.17. What is the ratio of the SF6 emissions (in thousand metric tons of CO2 equivalent) of 2005 in New Zealand to that in Pakistan?
Ensure brevity in your answer.  0.07. What is the ratio of the SF6 emissions (in thousand metric tons of CO2 equivalent) of 2008 in New Zealand to that in Pakistan?
Your response must be concise. 0.06. What is the ratio of the SF6 emissions (in thousand metric tons of CO2 equivalent) in 1990 in New Zealand to that in Philippines?
Provide a short and direct response. 0.31. What is the ratio of the SF6 emissions (in thousand metric tons of CO2 equivalent) in 2000 in New Zealand to that in Philippines?
Your answer should be very brief. 0.26. What is the ratio of the SF6 emissions (in thousand metric tons of CO2 equivalent) in 2005 in New Zealand to that in Philippines?
Keep it short and to the point. 0.15. What is the ratio of the SF6 emissions (in thousand metric tons of CO2 equivalent) of 2008 in New Zealand to that in Philippines?
Offer a terse response. 0.15. What is the ratio of the SF6 emissions (in thousand metric tons of CO2 equivalent) in 1990 in Nigeria to that in Norway?
Offer a terse response. 0.11. What is the ratio of the SF6 emissions (in thousand metric tons of CO2 equivalent) in 2000 in Nigeria to that in Norway?
Your answer should be very brief. 0.19. What is the ratio of the SF6 emissions (in thousand metric tons of CO2 equivalent) of 2005 in Nigeria to that in Norway?
Your response must be concise. 0.99. What is the ratio of the SF6 emissions (in thousand metric tons of CO2 equivalent) in 2008 in Nigeria to that in Norway?
Offer a terse response. 1.76. What is the ratio of the SF6 emissions (in thousand metric tons of CO2 equivalent) of 1990 in Nigeria to that in Pakistan?
Your response must be concise. 0.24. What is the ratio of the SF6 emissions (in thousand metric tons of CO2 equivalent) in 2000 in Nigeria to that in Pakistan?
Offer a very short reply. 0.53. What is the ratio of the SF6 emissions (in thousand metric tons of CO2 equivalent) in 2005 in Nigeria to that in Pakistan?
Give a very brief answer. 0.4. What is the ratio of the SF6 emissions (in thousand metric tons of CO2 equivalent) in 2008 in Nigeria to that in Pakistan?
Ensure brevity in your answer.  0.41. What is the ratio of the SF6 emissions (in thousand metric tons of CO2 equivalent) in 1990 in Nigeria to that in Philippines?
Provide a succinct answer. 1.49. What is the ratio of the SF6 emissions (in thousand metric tons of CO2 equivalent) of 2000 in Nigeria to that in Philippines?
Ensure brevity in your answer.  0.83. What is the ratio of the SF6 emissions (in thousand metric tons of CO2 equivalent) of 2005 in Nigeria to that in Philippines?
Ensure brevity in your answer.  0.89. What is the ratio of the SF6 emissions (in thousand metric tons of CO2 equivalent) of 2008 in Nigeria to that in Philippines?
Your answer should be compact. 0.93. What is the ratio of the SF6 emissions (in thousand metric tons of CO2 equivalent) of 1990 in Norway to that in Pakistan?
Provide a succinct answer. 2.24. What is the ratio of the SF6 emissions (in thousand metric tons of CO2 equivalent) in 2000 in Norway to that in Pakistan?
Ensure brevity in your answer.  2.83. What is the ratio of the SF6 emissions (in thousand metric tons of CO2 equivalent) in 2005 in Norway to that in Pakistan?
Your response must be concise. 0.4. What is the ratio of the SF6 emissions (in thousand metric tons of CO2 equivalent) of 2008 in Norway to that in Pakistan?
Provide a short and direct response. 0.23. What is the ratio of the SF6 emissions (in thousand metric tons of CO2 equivalent) in 1990 in Norway to that in Philippines?
Make the answer very short. 13.98. What is the ratio of the SF6 emissions (in thousand metric tons of CO2 equivalent) in 2000 in Norway to that in Philippines?
Ensure brevity in your answer.  4.44. What is the ratio of the SF6 emissions (in thousand metric tons of CO2 equivalent) of 2005 in Norway to that in Philippines?
Your answer should be compact. 0.91. What is the ratio of the SF6 emissions (in thousand metric tons of CO2 equivalent) in 2008 in Norway to that in Philippines?
Give a very brief answer. 0.53. What is the ratio of the SF6 emissions (in thousand metric tons of CO2 equivalent) of 1990 in Pakistan to that in Philippines?
Your answer should be compact. 6.23. What is the ratio of the SF6 emissions (in thousand metric tons of CO2 equivalent) of 2000 in Pakistan to that in Philippines?
Provide a succinct answer. 1.57. What is the ratio of the SF6 emissions (in thousand metric tons of CO2 equivalent) of 2005 in Pakistan to that in Philippines?
Provide a short and direct response. 2.24. What is the ratio of the SF6 emissions (in thousand metric tons of CO2 equivalent) of 2008 in Pakistan to that in Philippines?
Your answer should be compact. 2.26. What is the difference between the highest and the second highest SF6 emissions (in thousand metric tons of CO2 equivalent) of 1990?
Ensure brevity in your answer.  1254.6. What is the difference between the highest and the second highest SF6 emissions (in thousand metric tons of CO2 equivalent) in 2000?
Offer a terse response. 636. What is the difference between the highest and the second highest SF6 emissions (in thousand metric tons of CO2 equivalent) in 2005?
Make the answer very short. 454.1. What is the difference between the highest and the second highest SF6 emissions (in thousand metric tons of CO2 equivalent) of 2008?
Your answer should be compact. 529.9. What is the difference between the highest and the lowest SF6 emissions (in thousand metric tons of CO2 equivalent) of 1990?
Offer a terse response. 2214.2. What is the difference between the highest and the lowest SF6 emissions (in thousand metric tons of CO2 equivalent) of 2000?
Offer a very short reply. 924.8. What is the difference between the highest and the lowest SF6 emissions (in thousand metric tons of CO2 equivalent) in 2005?
Your response must be concise. 766. What is the difference between the highest and the lowest SF6 emissions (in thousand metric tons of CO2 equivalent) of 2008?
Your response must be concise. 890.1. 